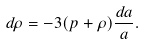Convert formula to latex. <formula><loc_0><loc_0><loc_500><loc_500>d \rho = - 3 ( p + \rho ) \frac { d a } { a } .</formula> 